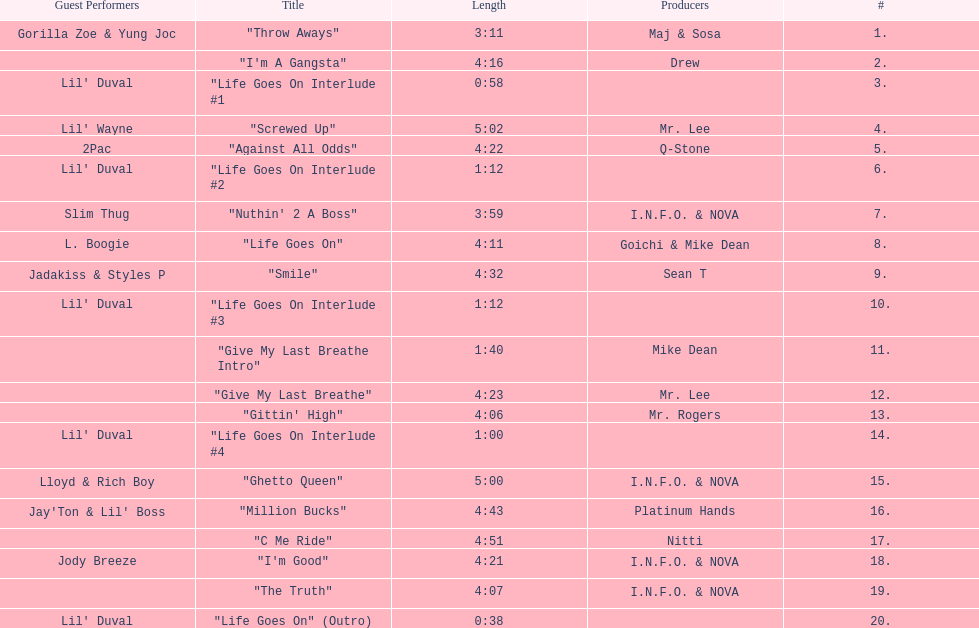What is the number of tracks on trae's "life goes on" album? 20. 